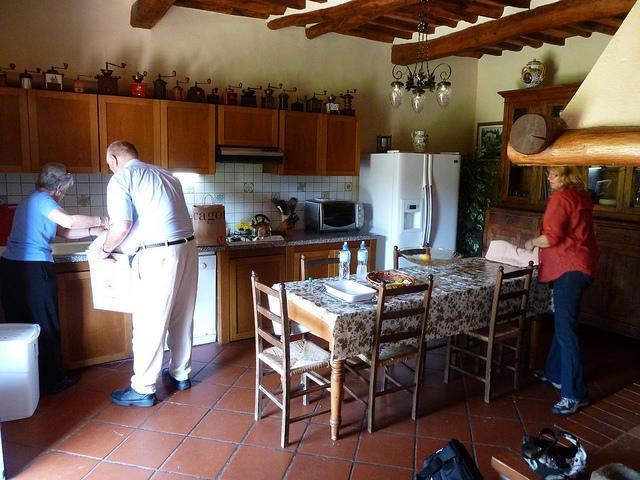How many chairs do you see?
Give a very brief answer. 5. How many potted plants are there?
Give a very brief answer. 1. How many people are visible?
Give a very brief answer. 3. How many chairs are there?
Give a very brief answer. 3. 